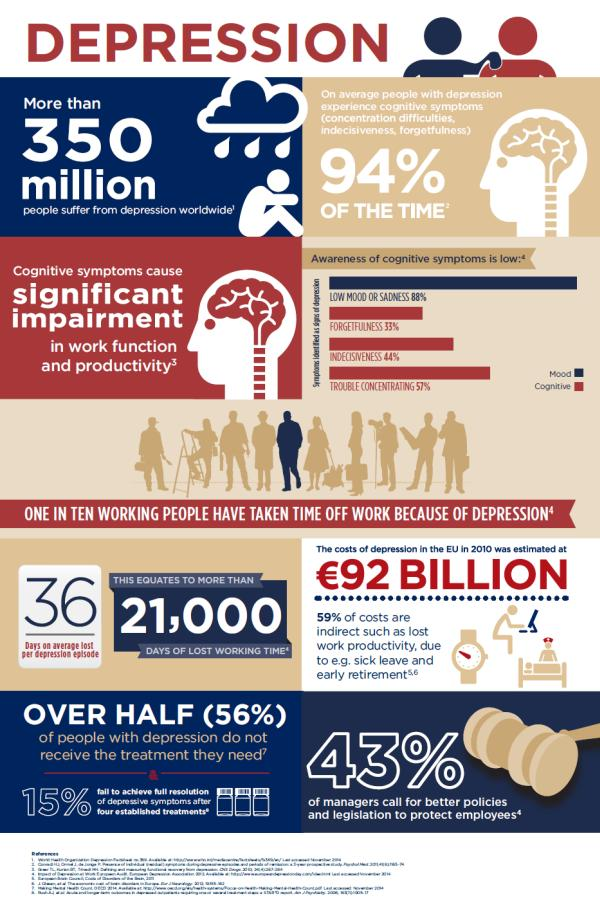Identify some key points in this picture. According to recent statistics, only 44% of individuals with depression receive the treatment they need. The combined percentage of forgetfulness and sadness is 121%. The color red is used to represent cognitive white. 